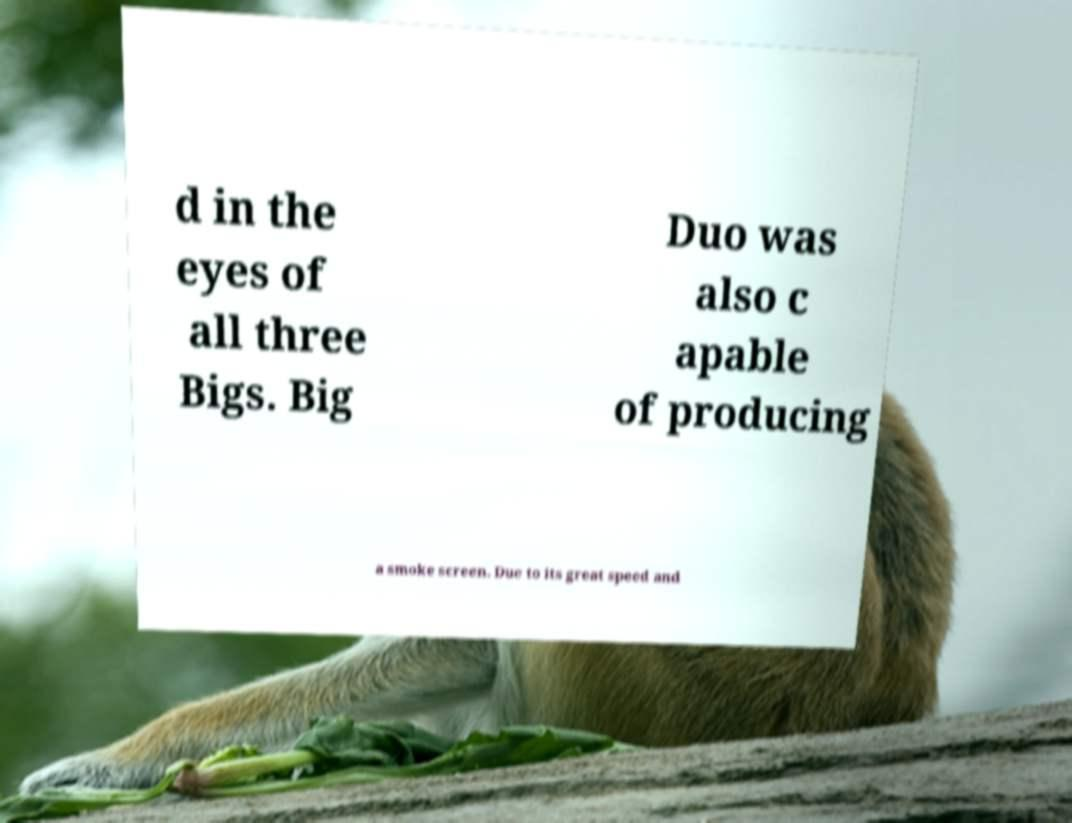What messages or text are displayed in this image? I need them in a readable, typed format. d in the eyes of all three Bigs. Big Duo was also c apable of producing a smoke screen. Due to its great speed and 